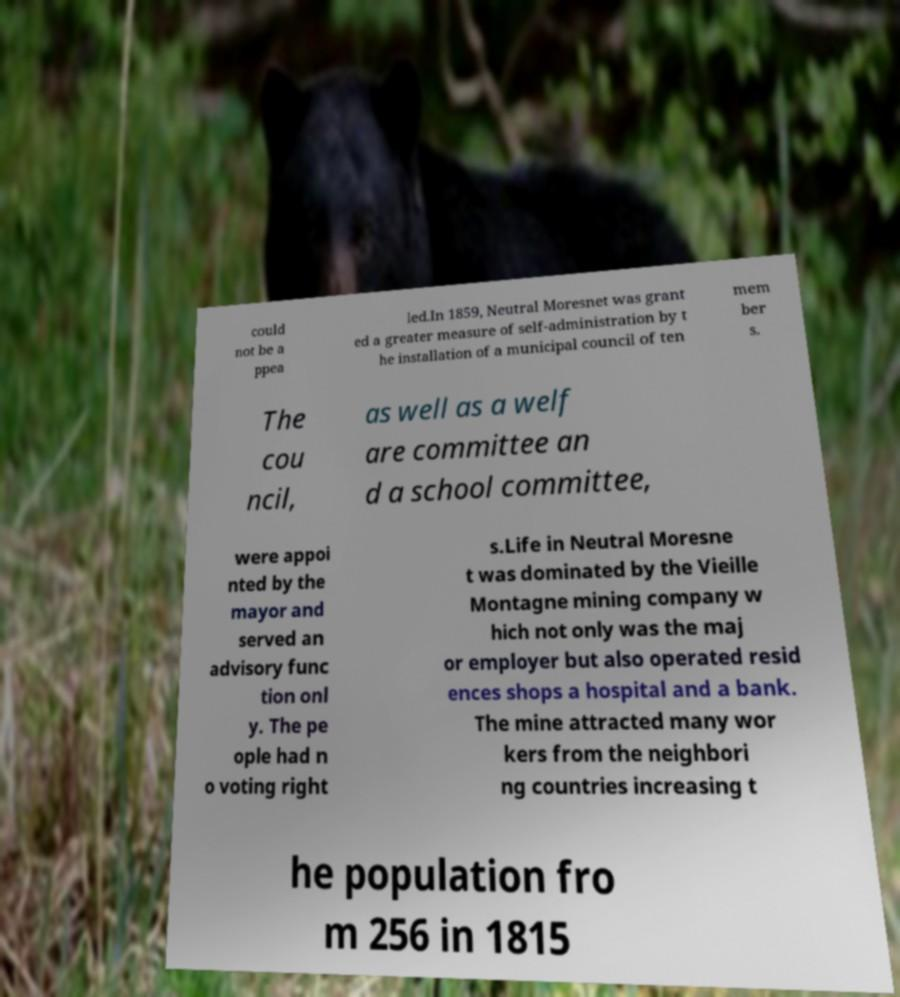Please read and relay the text visible in this image. What does it say? could not be a ppea led.In 1859, Neutral Moresnet was grant ed a greater measure of self-administration by t he installation of a municipal council of ten mem ber s. The cou ncil, as well as a welf are committee an d a school committee, were appoi nted by the mayor and served an advisory func tion onl y. The pe ople had n o voting right s.Life in Neutral Moresne t was dominated by the Vieille Montagne mining company w hich not only was the maj or employer but also operated resid ences shops a hospital and a bank. The mine attracted many wor kers from the neighbori ng countries increasing t he population fro m 256 in 1815 